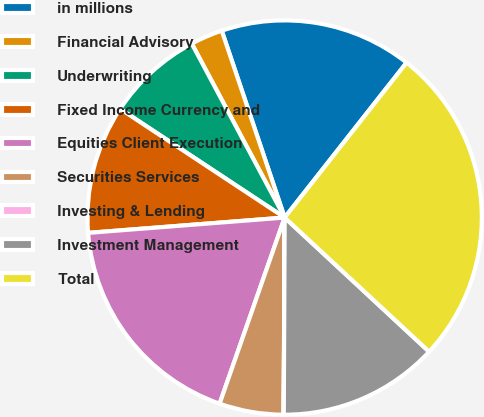Convert chart. <chart><loc_0><loc_0><loc_500><loc_500><pie_chart><fcel>in millions<fcel>Financial Advisory<fcel>Underwriting<fcel>Fixed Income Currency and<fcel>Equities Client Execution<fcel>Securities Services<fcel>Investing & Lending<fcel>Investment Management<fcel>Total<nl><fcel>15.78%<fcel>2.64%<fcel>7.9%<fcel>10.53%<fcel>18.41%<fcel>5.27%<fcel>0.01%<fcel>13.16%<fcel>26.3%<nl></chart> 